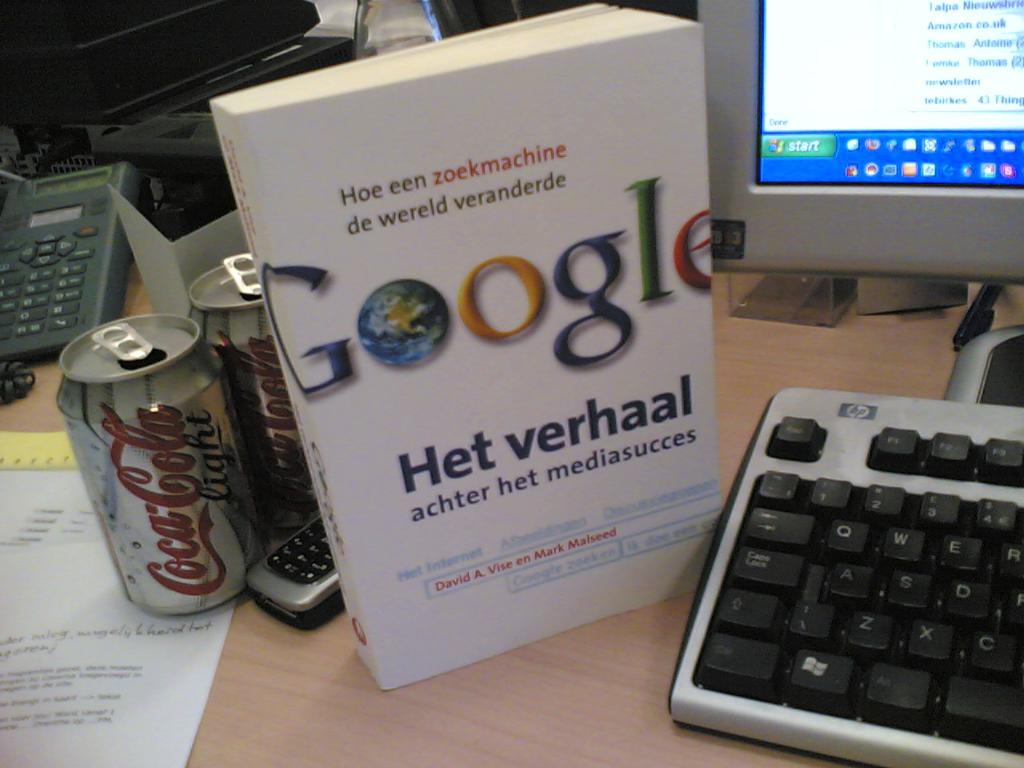What can you tell me about the significance of the Google book in the image? The book in the image, detailing Google's impact on the world, symbolizes the profound influence of digital technologies on modern society. Its presence not only signifies interest in technological evolution but also highlights the importance of understanding how such platforms can reshape communication, information dissemination, and media success globally. 